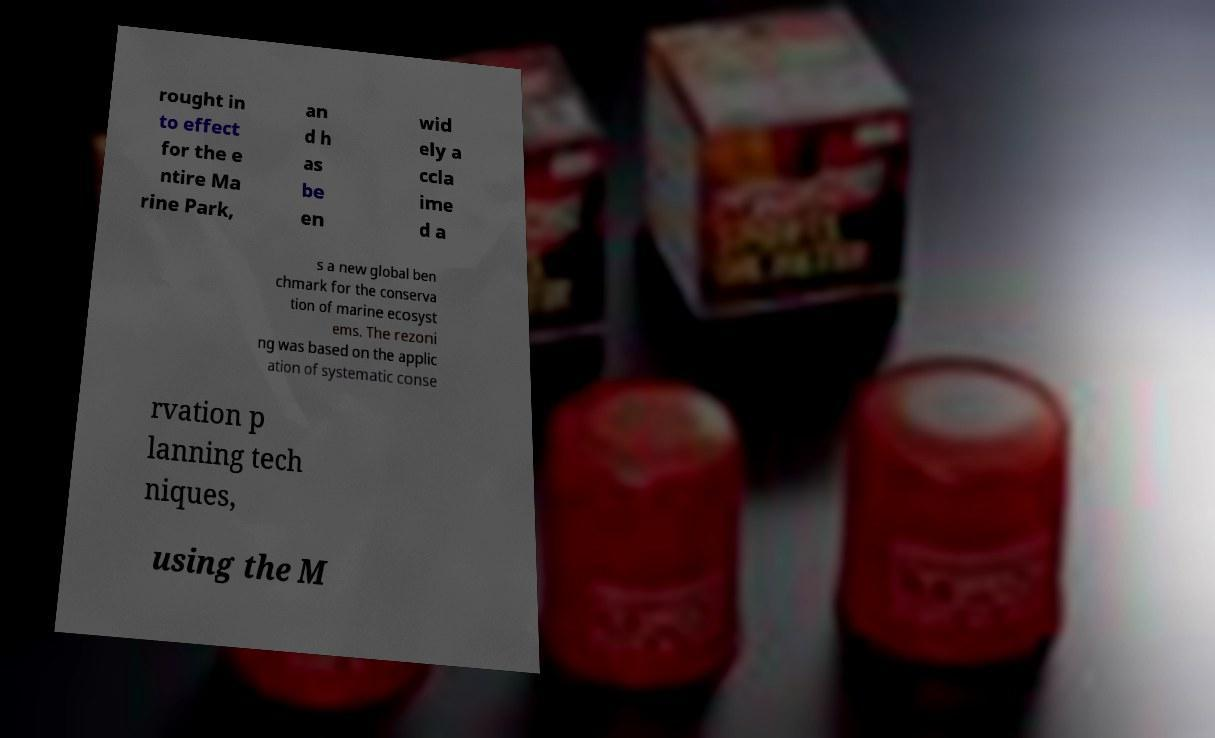There's text embedded in this image that I need extracted. Can you transcribe it verbatim? rought in to effect for the e ntire Ma rine Park, an d h as be en wid ely a ccla ime d a s a new global ben chmark for the conserva tion of marine ecosyst ems. The rezoni ng was based on the applic ation of systematic conse rvation p lanning tech niques, using the M 